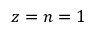Convert formula to latex. <formula><loc_0><loc_0><loc_500><loc_500>z = n = 1</formula> 